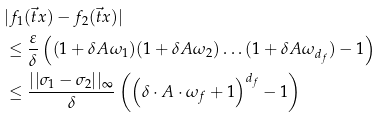Convert formula to latex. <formula><loc_0><loc_0><loc_500><loc_500>& | f _ { 1 } ( \vec { t } { x } ) - f _ { 2 } ( \vec { t } { x } ) | \\ & \leq \frac { \varepsilon } { \delta } \left ( ( 1 + \delta A \omega _ { 1 } ) ( 1 + \delta A \omega _ { 2 } ) \dots ( 1 + \delta A \omega _ { d _ { f } } ) - 1 \right ) \\ & \leq \frac { | | \sigma _ { 1 } - \sigma _ { 2 } | | _ { \infty } } { \delta } \left ( \left ( \delta \cdot A \cdot \omega _ { f } + 1 \right ) ^ { d _ { f } } - 1 \right )</formula> 